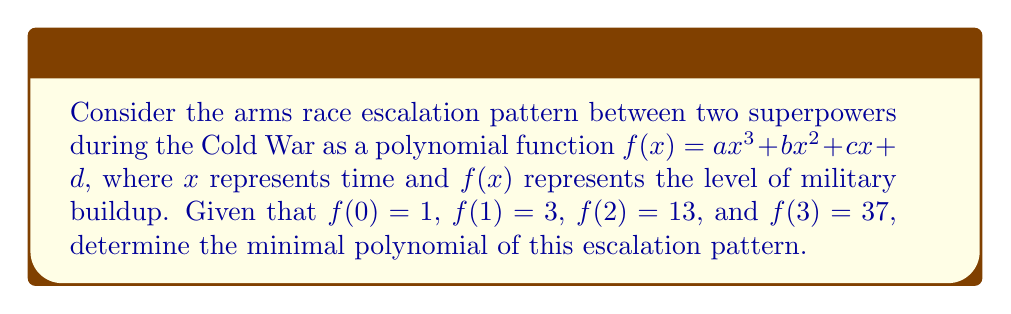Solve this math problem. To find the minimal polynomial, we need to:

1. Determine the coefficients of $f(x)$:
   Using the given points, we can set up a system of equations:
   $$ \begin{cases}
   d = 1 \\
   a + b + c + d = 3 \\
   8a + 4b + 2c + d = 13 \\
   27a + 9b + 3c + d = 37
   \end{cases} $$

2. Solve the system of equations:
   $$ \begin{aligned}
   d &= 1 \\
   c &= 1 \\
   b &= 0 \\
   a &= 1
   \end{aligned} $$

3. Write the polynomial:
   $$ f(x) = x^3 + x + 1 $$

4. Since this polynomial is of degree 3 and has integer coefficients, it is likely to be the minimal polynomial. To confirm, we need to check if it's irreducible over $\mathbb{Q}$.

5. Apply the rational root test:
   Possible rational roots: $\pm 1$
   Neither of these are roots of $f(x)$, so the polynomial is irreducible over $\mathbb{Q}$.

Therefore, $x^3 + x + 1$ is the minimal polynomial of this arms race escalation pattern.
Answer: $x^3 + x + 1$ 